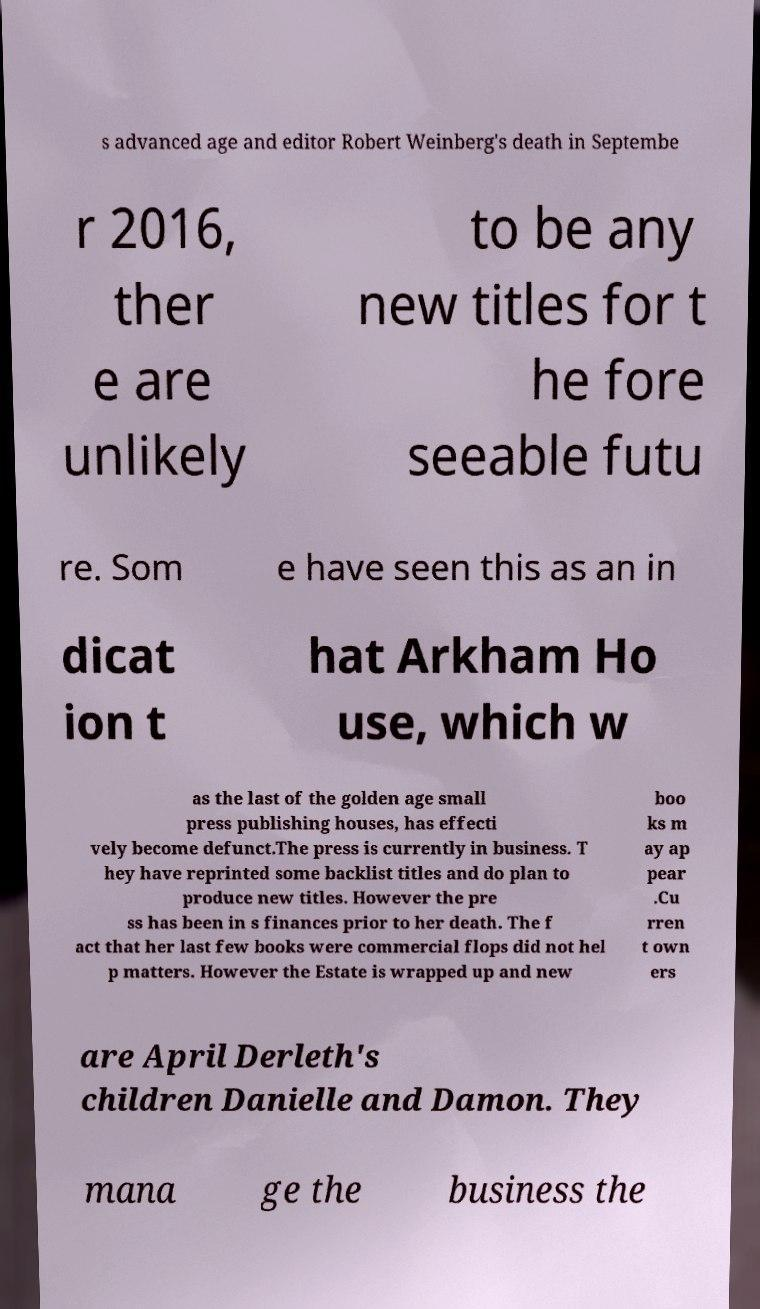For documentation purposes, I need the text within this image transcribed. Could you provide that? s advanced age and editor Robert Weinberg's death in Septembe r 2016, ther e are unlikely to be any new titles for t he fore seeable futu re. Som e have seen this as an in dicat ion t hat Arkham Ho use, which w as the last of the golden age small press publishing houses, has effecti vely become defunct.The press is currently in business. T hey have reprinted some backlist titles and do plan to produce new titles. However the pre ss has been in s finances prior to her death. The f act that her last few books were commercial flops did not hel p matters. However the Estate is wrapped up and new boo ks m ay ap pear .Cu rren t own ers are April Derleth's children Danielle and Damon. They mana ge the business the 